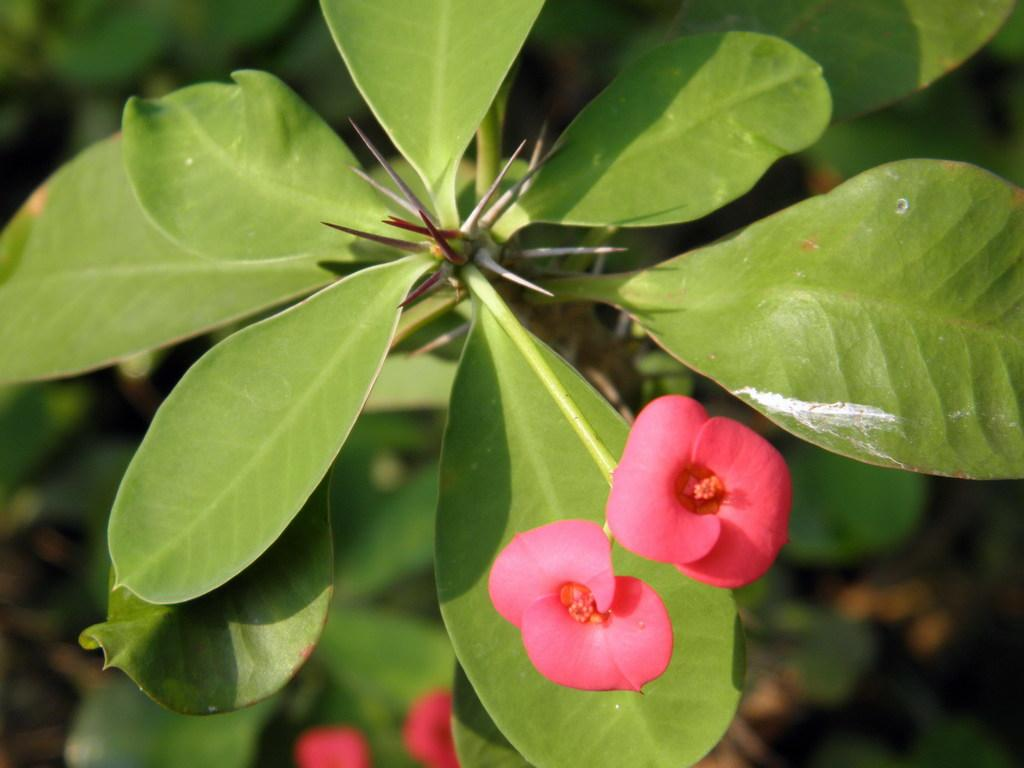What type of living organism can be seen in the picture? There is a plant in the picture. Can you describe the leaves of the plant? The plant has huge leaves. How many flowers are on the plant? There are two flowers on the plant. What color are the flowers? The flowers are pink in color. What type of cushion is used to support the plant's wing in the image? There is no cushion or wing present in the image; it features a plant with huge leaves and pink flowers. 